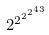<formula> <loc_0><loc_0><loc_500><loc_500>2 ^ { 2 ^ { 2 ^ { 2 ^ { 4 3 } } } }</formula> 